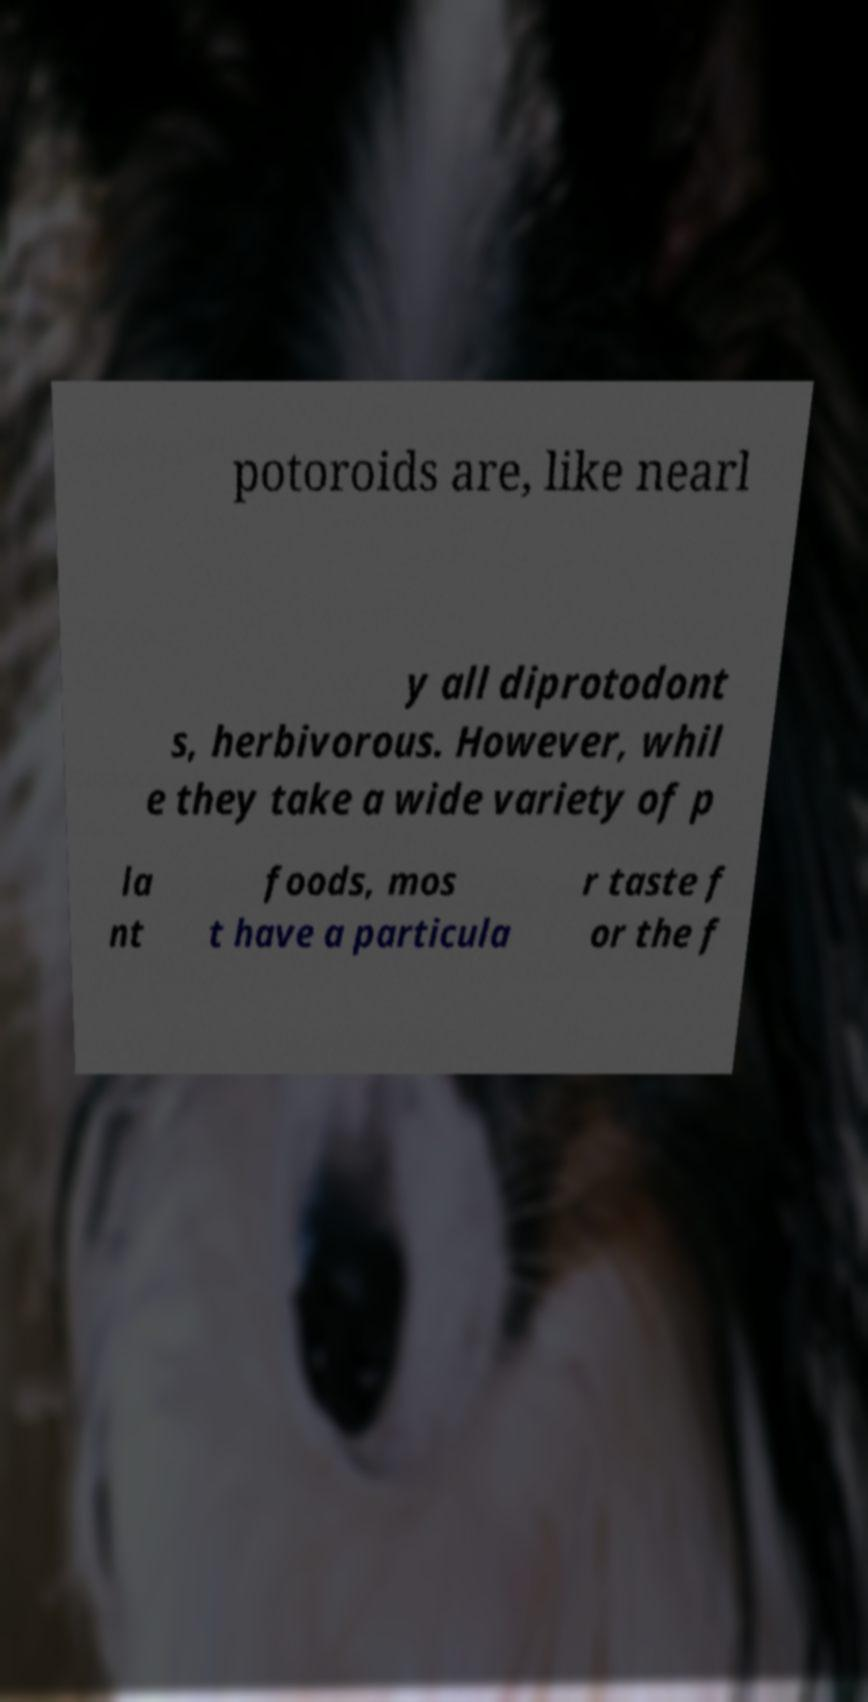Could you extract and type out the text from this image? potoroids are, like nearl y all diprotodont s, herbivorous. However, whil e they take a wide variety of p la nt foods, mos t have a particula r taste f or the f 